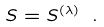<formula> <loc_0><loc_0><loc_500><loc_500>S = S ^ { ( \lambda ) } \ .</formula> 